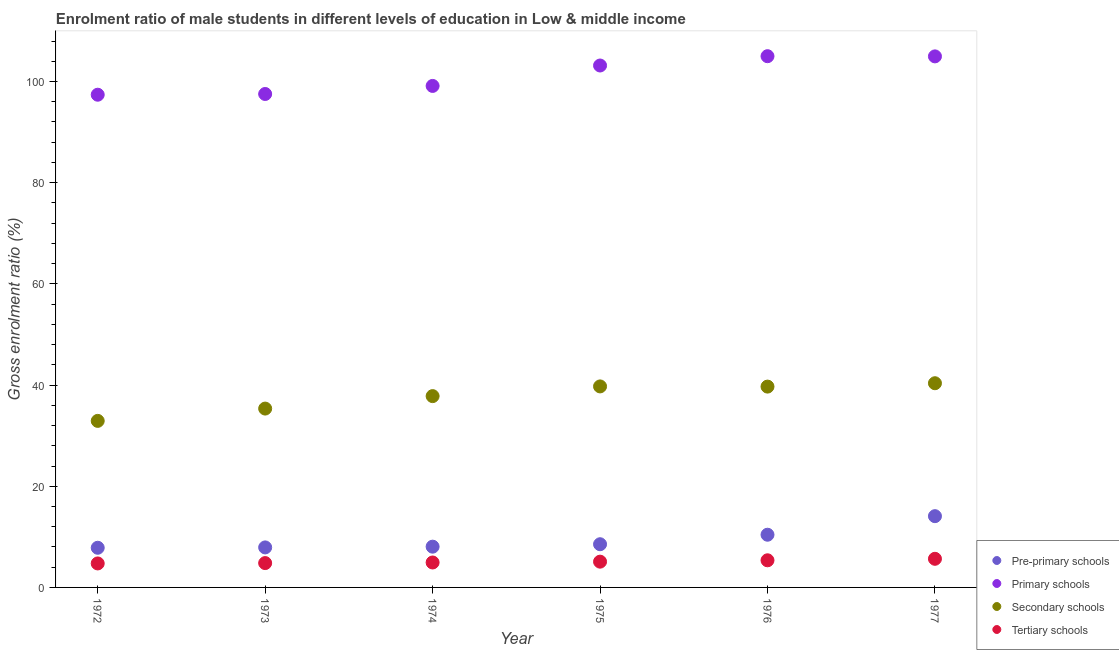How many different coloured dotlines are there?
Provide a short and direct response. 4. What is the gross enrolment ratio(female) in tertiary schools in 1977?
Give a very brief answer. 5.66. Across all years, what is the maximum gross enrolment ratio(female) in secondary schools?
Offer a terse response. 40.36. Across all years, what is the minimum gross enrolment ratio(female) in secondary schools?
Provide a succinct answer. 32.92. In which year was the gross enrolment ratio(female) in primary schools maximum?
Your answer should be compact. 1976. What is the total gross enrolment ratio(female) in primary schools in the graph?
Your answer should be compact. 607.19. What is the difference between the gross enrolment ratio(female) in pre-primary schools in 1976 and that in 1977?
Ensure brevity in your answer.  -3.67. What is the difference between the gross enrolment ratio(female) in tertiary schools in 1972 and the gross enrolment ratio(female) in secondary schools in 1976?
Give a very brief answer. -34.95. What is the average gross enrolment ratio(female) in pre-primary schools per year?
Provide a short and direct response. 9.47. In the year 1976, what is the difference between the gross enrolment ratio(female) in primary schools and gross enrolment ratio(female) in tertiary schools?
Provide a short and direct response. 99.64. In how many years, is the gross enrolment ratio(female) in secondary schools greater than 44 %?
Keep it short and to the point. 0. What is the ratio of the gross enrolment ratio(female) in tertiary schools in 1975 to that in 1977?
Provide a short and direct response. 0.9. Is the gross enrolment ratio(female) in pre-primary schools in 1974 less than that in 1977?
Provide a short and direct response. Yes. Is the difference between the gross enrolment ratio(female) in tertiary schools in 1972 and 1975 greater than the difference between the gross enrolment ratio(female) in pre-primary schools in 1972 and 1975?
Make the answer very short. Yes. What is the difference between the highest and the second highest gross enrolment ratio(female) in pre-primary schools?
Offer a terse response. 3.67. What is the difference between the highest and the lowest gross enrolment ratio(female) in secondary schools?
Ensure brevity in your answer.  7.44. Is it the case that in every year, the sum of the gross enrolment ratio(female) in pre-primary schools and gross enrolment ratio(female) in primary schools is greater than the gross enrolment ratio(female) in secondary schools?
Give a very brief answer. Yes. Is the gross enrolment ratio(female) in primary schools strictly greater than the gross enrolment ratio(female) in tertiary schools over the years?
Keep it short and to the point. Yes. What is the difference between two consecutive major ticks on the Y-axis?
Your answer should be very brief. 20. What is the title of the graph?
Your answer should be compact. Enrolment ratio of male students in different levels of education in Low & middle income. Does "Revenue mobilization" appear as one of the legend labels in the graph?
Provide a short and direct response. No. What is the Gross enrolment ratio (%) of Pre-primary schools in 1972?
Provide a short and direct response. 7.84. What is the Gross enrolment ratio (%) in Primary schools in 1972?
Make the answer very short. 97.39. What is the Gross enrolment ratio (%) of Secondary schools in 1972?
Keep it short and to the point. 32.92. What is the Gross enrolment ratio (%) of Tertiary schools in 1972?
Give a very brief answer. 4.74. What is the Gross enrolment ratio (%) of Pre-primary schools in 1973?
Provide a short and direct response. 7.91. What is the Gross enrolment ratio (%) in Primary schools in 1973?
Offer a very short reply. 97.53. What is the Gross enrolment ratio (%) in Secondary schools in 1973?
Give a very brief answer. 35.35. What is the Gross enrolment ratio (%) of Tertiary schools in 1973?
Provide a short and direct response. 4.81. What is the Gross enrolment ratio (%) in Pre-primary schools in 1974?
Give a very brief answer. 8.06. What is the Gross enrolment ratio (%) of Primary schools in 1974?
Your answer should be compact. 99.13. What is the Gross enrolment ratio (%) in Secondary schools in 1974?
Provide a short and direct response. 37.81. What is the Gross enrolment ratio (%) in Tertiary schools in 1974?
Give a very brief answer. 4.93. What is the Gross enrolment ratio (%) of Pre-primary schools in 1975?
Offer a terse response. 8.54. What is the Gross enrolment ratio (%) of Primary schools in 1975?
Give a very brief answer. 103.16. What is the Gross enrolment ratio (%) in Secondary schools in 1975?
Offer a terse response. 39.73. What is the Gross enrolment ratio (%) in Tertiary schools in 1975?
Make the answer very short. 5.09. What is the Gross enrolment ratio (%) in Pre-primary schools in 1976?
Your answer should be very brief. 10.42. What is the Gross enrolment ratio (%) in Primary schools in 1976?
Ensure brevity in your answer.  105.01. What is the Gross enrolment ratio (%) of Secondary schools in 1976?
Offer a terse response. 39.69. What is the Gross enrolment ratio (%) of Tertiary schools in 1976?
Make the answer very short. 5.36. What is the Gross enrolment ratio (%) in Pre-primary schools in 1977?
Ensure brevity in your answer.  14.09. What is the Gross enrolment ratio (%) of Primary schools in 1977?
Offer a terse response. 104.97. What is the Gross enrolment ratio (%) in Secondary schools in 1977?
Give a very brief answer. 40.36. What is the Gross enrolment ratio (%) of Tertiary schools in 1977?
Keep it short and to the point. 5.66. Across all years, what is the maximum Gross enrolment ratio (%) of Pre-primary schools?
Provide a short and direct response. 14.09. Across all years, what is the maximum Gross enrolment ratio (%) of Primary schools?
Offer a terse response. 105.01. Across all years, what is the maximum Gross enrolment ratio (%) of Secondary schools?
Keep it short and to the point. 40.36. Across all years, what is the maximum Gross enrolment ratio (%) in Tertiary schools?
Make the answer very short. 5.66. Across all years, what is the minimum Gross enrolment ratio (%) in Pre-primary schools?
Keep it short and to the point. 7.84. Across all years, what is the minimum Gross enrolment ratio (%) of Primary schools?
Your answer should be compact. 97.39. Across all years, what is the minimum Gross enrolment ratio (%) in Secondary schools?
Provide a short and direct response. 32.92. Across all years, what is the minimum Gross enrolment ratio (%) of Tertiary schools?
Your answer should be compact. 4.74. What is the total Gross enrolment ratio (%) in Pre-primary schools in the graph?
Provide a succinct answer. 56.85. What is the total Gross enrolment ratio (%) of Primary schools in the graph?
Offer a terse response. 607.19. What is the total Gross enrolment ratio (%) in Secondary schools in the graph?
Provide a succinct answer. 225.87. What is the total Gross enrolment ratio (%) in Tertiary schools in the graph?
Keep it short and to the point. 30.6. What is the difference between the Gross enrolment ratio (%) of Pre-primary schools in 1972 and that in 1973?
Make the answer very short. -0.07. What is the difference between the Gross enrolment ratio (%) of Primary schools in 1972 and that in 1973?
Offer a very short reply. -0.14. What is the difference between the Gross enrolment ratio (%) of Secondary schools in 1972 and that in 1973?
Provide a succinct answer. -2.43. What is the difference between the Gross enrolment ratio (%) of Tertiary schools in 1972 and that in 1973?
Offer a very short reply. -0.07. What is the difference between the Gross enrolment ratio (%) in Pre-primary schools in 1972 and that in 1974?
Provide a succinct answer. -0.22. What is the difference between the Gross enrolment ratio (%) of Primary schools in 1972 and that in 1974?
Keep it short and to the point. -1.74. What is the difference between the Gross enrolment ratio (%) of Secondary schools in 1972 and that in 1974?
Your answer should be very brief. -4.9. What is the difference between the Gross enrolment ratio (%) of Tertiary schools in 1972 and that in 1974?
Offer a very short reply. -0.19. What is the difference between the Gross enrolment ratio (%) in Pre-primary schools in 1972 and that in 1975?
Provide a succinct answer. -0.7. What is the difference between the Gross enrolment ratio (%) in Primary schools in 1972 and that in 1975?
Provide a short and direct response. -5.77. What is the difference between the Gross enrolment ratio (%) in Secondary schools in 1972 and that in 1975?
Your answer should be compact. -6.81. What is the difference between the Gross enrolment ratio (%) of Tertiary schools in 1972 and that in 1975?
Your answer should be compact. -0.35. What is the difference between the Gross enrolment ratio (%) of Pre-primary schools in 1972 and that in 1976?
Your answer should be very brief. -2.58. What is the difference between the Gross enrolment ratio (%) in Primary schools in 1972 and that in 1976?
Ensure brevity in your answer.  -7.62. What is the difference between the Gross enrolment ratio (%) of Secondary schools in 1972 and that in 1976?
Make the answer very short. -6.78. What is the difference between the Gross enrolment ratio (%) of Tertiary schools in 1972 and that in 1976?
Offer a very short reply. -0.62. What is the difference between the Gross enrolment ratio (%) in Pre-primary schools in 1972 and that in 1977?
Provide a succinct answer. -6.25. What is the difference between the Gross enrolment ratio (%) of Primary schools in 1972 and that in 1977?
Ensure brevity in your answer.  -7.58. What is the difference between the Gross enrolment ratio (%) of Secondary schools in 1972 and that in 1977?
Provide a short and direct response. -7.44. What is the difference between the Gross enrolment ratio (%) of Tertiary schools in 1972 and that in 1977?
Give a very brief answer. -0.92. What is the difference between the Gross enrolment ratio (%) in Pre-primary schools in 1973 and that in 1974?
Provide a succinct answer. -0.15. What is the difference between the Gross enrolment ratio (%) in Primary schools in 1973 and that in 1974?
Provide a short and direct response. -1.59. What is the difference between the Gross enrolment ratio (%) in Secondary schools in 1973 and that in 1974?
Provide a succinct answer. -2.46. What is the difference between the Gross enrolment ratio (%) in Tertiary schools in 1973 and that in 1974?
Provide a succinct answer. -0.12. What is the difference between the Gross enrolment ratio (%) of Pre-primary schools in 1973 and that in 1975?
Provide a succinct answer. -0.63. What is the difference between the Gross enrolment ratio (%) of Primary schools in 1973 and that in 1975?
Give a very brief answer. -5.63. What is the difference between the Gross enrolment ratio (%) in Secondary schools in 1973 and that in 1975?
Provide a short and direct response. -4.38. What is the difference between the Gross enrolment ratio (%) in Tertiary schools in 1973 and that in 1975?
Your answer should be compact. -0.28. What is the difference between the Gross enrolment ratio (%) of Pre-primary schools in 1973 and that in 1976?
Your answer should be compact. -2.51. What is the difference between the Gross enrolment ratio (%) in Primary schools in 1973 and that in 1976?
Keep it short and to the point. -7.47. What is the difference between the Gross enrolment ratio (%) in Secondary schools in 1973 and that in 1976?
Your answer should be compact. -4.34. What is the difference between the Gross enrolment ratio (%) in Tertiary schools in 1973 and that in 1976?
Your response must be concise. -0.55. What is the difference between the Gross enrolment ratio (%) in Pre-primary schools in 1973 and that in 1977?
Your answer should be compact. -6.18. What is the difference between the Gross enrolment ratio (%) of Primary schools in 1973 and that in 1977?
Your answer should be compact. -7.43. What is the difference between the Gross enrolment ratio (%) of Secondary schools in 1973 and that in 1977?
Your response must be concise. -5.01. What is the difference between the Gross enrolment ratio (%) of Tertiary schools in 1973 and that in 1977?
Give a very brief answer. -0.85. What is the difference between the Gross enrolment ratio (%) of Pre-primary schools in 1974 and that in 1975?
Provide a succinct answer. -0.48. What is the difference between the Gross enrolment ratio (%) of Primary schools in 1974 and that in 1975?
Provide a short and direct response. -4.04. What is the difference between the Gross enrolment ratio (%) in Secondary schools in 1974 and that in 1975?
Provide a succinct answer. -1.92. What is the difference between the Gross enrolment ratio (%) in Tertiary schools in 1974 and that in 1975?
Provide a succinct answer. -0.16. What is the difference between the Gross enrolment ratio (%) of Pre-primary schools in 1974 and that in 1976?
Ensure brevity in your answer.  -2.36. What is the difference between the Gross enrolment ratio (%) in Primary schools in 1974 and that in 1976?
Provide a short and direct response. -5.88. What is the difference between the Gross enrolment ratio (%) of Secondary schools in 1974 and that in 1976?
Keep it short and to the point. -1.88. What is the difference between the Gross enrolment ratio (%) of Tertiary schools in 1974 and that in 1976?
Give a very brief answer. -0.43. What is the difference between the Gross enrolment ratio (%) of Pre-primary schools in 1974 and that in 1977?
Make the answer very short. -6.03. What is the difference between the Gross enrolment ratio (%) in Primary schools in 1974 and that in 1977?
Your response must be concise. -5.84. What is the difference between the Gross enrolment ratio (%) of Secondary schools in 1974 and that in 1977?
Provide a succinct answer. -2.55. What is the difference between the Gross enrolment ratio (%) in Tertiary schools in 1974 and that in 1977?
Offer a terse response. -0.73. What is the difference between the Gross enrolment ratio (%) of Pre-primary schools in 1975 and that in 1976?
Provide a succinct answer. -1.88. What is the difference between the Gross enrolment ratio (%) in Primary schools in 1975 and that in 1976?
Provide a short and direct response. -1.84. What is the difference between the Gross enrolment ratio (%) in Secondary schools in 1975 and that in 1976?
Your answer should be compact. 0.04. What is the difference between the Gross enrolment ratio (%) in Tertiary schools in 1975 and that in 1976?
Make the answer very short. -0.27. What is the difference between the Gross enrolment ratio (%) of Pre-primary schools in 1975 and that in 1977?
Ensure brevity in your answer.  -5.55. What is the difference between the Gross enrolment ratio (%) of Primary schools in 1975 and that in 1977?
Keep it short and to the point. -1.8. What is the difference between the Gross enrolment ratio (%) of Secondary schools in 1975 and that in 1977?
Provide a short and direct response. -0.63. What is the difference between the Gross enrolment ratio (%) in Tertiary schools in 1975 and that in 1977?
Your answer should be compact. -0.57. What is the difference between the Gross enrolment ratio (%) of Pre-primary schools in 1976 and that in 1977?
Keep it short and to the point. -3.67. What is the difference between the Gross enrolment ratio (%) of Primary schools in 1976 and that in 1977?
Offer a terse response. 0.04. What is the difference between the Gross enrolment ratio (%) of Secondary schools in 1976 and that in 1977?
Make the answer very short. -0.67. What is the difference between the Gross enrolment ratio (%) of Tertiary schools in 1976 and that in 1977?
Give a very brief answer. -0.3. What is the difference between the Gross enrolment ratio (%) of Pre-primary schools in 1972 and the Gross enrolment ratio (%) of Primary schools in 1973?
Provide a short and direct response. -89.7. What is the difference between the Gross enrolment ratio (%) in Pre-primary schools in 1972 and the Gross enrolment ratio (%) in Secondary schools in 1973?
Offer a very short reply. -27.51. What is the difference between the Gross enrolment ratio (%) of Pre-primary schools in 1972 and the Gross enrolment ratio (%) of Tertiary schools in 1973?
Make the answer very short. 3.03. What is the difference between the Gross enrolment ratio (%) of Primary schools in 1972 and the Gross enrolment ratio (%) of Secondary schools in 1973?
Provide a short and direct response. 62.04. What is the difference between the Gross enrolment ratio (%) of Primary schools in 1972 and the Gross enrolment ratio (%) of Tertiary schools in 1973?
Ensure brevity in your answer.  92.58. What is the difference between the Gross enrolment ratio (%) in Secondary schools in 1972 and the Gross enrolment ratio (%) in Tertiary schools in 1973?
Your response must be concise. 28.11. What is the difference between the Gross enrolment ratio (%) in Pre-primary schools in 1972 and the Gross enrolment ratio (%) in Primary schools in 1974?
Give a very brief answer. -91.29. What is the difference between the Gross enrolment ratio (%) in Pre-primary schools in 1972 and the Gross enrolment ratio (%) in Secondary schools in 1974?
Provide a succinct answer. -29.98. What is the difference between the Gross enrolment ratio (%) of Pre-primary schools in 1972 and the Gross enrolment ratio (%) of Tertiary schools in 1974?
Provide a short and direct response. 2.91. What is the difference between the Gross enrolment ratio (%) of Primary schools in 1972 and the Gross enrolment ratio (%) of Secondary schools in 1974?
Provide a short and direct response. 59.58. What is the difference between the Gross enrolment ratio (%) of Primary schools in 1972 and the Gross enrolment ratio (%) of Tertiary schools in 1974?
Your answer should be compact. 92.46. What is the difference between the Gross enrolment ratio (%) of Secondary schools in 1972 and the Gross enrolment ratio (%) of Tertiary schools in 1974?
Provide a short and direct response. 27.99. What is the difference between the Gross enrolment ratio (%) in Pre-primary schools in 1972 and the Gross enrolment ratio (%) in Primary schools in 1975?
Provide a succinct answer. -95.32. What is the difference between the Gross enrolment ratio (%) of Pre-primary schools in 1972 and the Gross enrolment ratio (%) of Secondary schools in 1975?
Your response must be concise. -31.89. What is the difference between the Gross enrolment ratio (%) in Pre-primary schools in 1972 and the Gross enrolment ratio (%) in Tertiary schools in 1975?
Ensure brevity in your answer.  2.75. What is the difference between the Gross enrolment ratio (%) of Primary schools in 1972 and the Gross enrolment ratio (%) of Secondary schools in 1975?
Provide a short and direct response. 57.66. What is the difference between the Gross enrolment ratio (%) of Primary schools in 1972 and the Gross enrolment ratio (%) of Tertiary schools in 1975?
Your answer should be very brief. 92.3. What is the difference between the Gross enrolment ratio (%) of Secondary schools in 1972 and the Gross enrolment ratio (%) of Tertiary schools in 1975?
Keep it short and to the point. 27.83. What is the difference between the Gross enrolment ratio (%) in Pre-primary schools in 1972 and the Gross enrolment ratio (%) in Primary schools in 1976?
Keep it short and to the point. -97.17. What is the difference between the Gross enrolment ratio (%) of Pre-primary schools in 1972 and the Gross enrolment ratio (%) of Secondary schools in 1976?
Your answer should be very brief. -31.86. What is the difference between the Gross enrolment ratio (%) of Pre-primary schools in 1972 and the Gross enrolment ratio (%) of Tertiary schools in 1976?
Provide a short and direct response. 2.48. What is the difference between the Gross enrolment ratio (%) in Primary schools in 1972 and the Gross enrolment ratio (%) in Secondary schools in 1976?
Your answer should be very brief. 57.7. What is the difference between the Gross enrolment ratio (%) in Primary schools in 1972 and the Gross enrolment ratio (%) in Tertiary schools in 1976?
Your response must be concise. 92.03. What is the difference between the Gross enrolment ratio (%) in Secondary schools in 1972 and the Gross enrolment ratio (%) in Tertiary schools in 1976?
Keep it short and to the point. 27.56. What is the difference between the Gross enrolment ratio (%) of Pre-primary schools in 1972 and the Gross enrolment ratio (%) of Primary schools in 1977?
Provide a short and direct response. -97.13. What is the difference between the Gross enrolment ratio (%) in Pre-primary schools in 1972 and the Gross enrolment ratio (%) in Secondary schools in 1977?
Provide a short and direct response. -32.52. What is the difference between the Gross enrolment ratio (%) in Pre-primary schools in 1972 and the Gross enrolment ratio (%) in Tertiary schools in 1977?
Your response must be concise. 2.18. What is the difference between the Gross enrolment ratio (%) of Primary schools in 1972 and the Gross enrolment ratio (%) of Secondary schools in 1977?
Provide a succinct answer. 57.03. What is the difference between the Gross enrolment ratio (%) in Primary schools in 1972 and the Gross enrolment ratio (%) in Tertiary schools in 1977?
Provide a short and direct response. 91.73. What is the difference between the Gross enrolment ratio (%) in Secondary schools in 1972 and the Gross enrolment ratio (%) in Tertiary schools in 1977?
Your response must be concise. 27.26. What is the difference between the Gross enrolment ratio (%) of Pre-primary schools in 1973 and the Gross enrolment ratio (%) of Primary schools in 1974?
Your answer should be compact. -91.22. What is the difference between the Gross enrolment ratio (%) of Pre-primary schools in 1973 and the Gross enrolment ratio (%) of Secondary schools in 1974?
Offer a very short reply. -29.91. What is the difference between the Gross enrolment ratio (%) in Pre-primary schools in 1973 and the Gross enrolment ratio (%) in Tertiary schools in 1974?
Your answer should be compact. 2.98. What is the difference between the Gross enrolment ratio (%) in Primary schools in 1973 and the Gross enrolment ratio (%) in Secondary schools in 1974?
Provide a succinct answer. 59.72. What is the difference between the Gross enrolment ratio (%) in Primary schools in 1973 and the Gross enrolment ratio (%) in Tertiary schools in 1974?
Make the answer very short. 92.61. What is the difference between the Gross enrolment ratio (%) of Secondary schools in 1973 and the Gross enrolment ratio (%) of Tertiary schools in 1974?
Ensure brevity in your answer.  30.42. What is the difference between the Gross enrolment ratio (%) of Pre-primary schools in 1973 and the Gross enrolment ratio (%) of Primary schools in 1975?
Keep it short and to the point. -95.25. What is the difference between the Gross enrolment ratio (%) of Pre-primary schools in 1973 and the Gross enrolment ratio (%) of Secondary schools in 1975?
Offer a very short reply. -31.82. What is the difference between the Gross enrolment ratio (%) of Pre-primary schools in 1973 and the Gross enrolment ratio (%) of Tertiary schools in 1975?
Provide a succinct answer. 2.82. What is the difference between the Gross enrolment ratio (%) of Primary schools in 1973 and the Gross enrolment ratio (%) of Secondary schools in 1975?
Offer a very short reply. 57.8. What is the difference between the Gross enrolment ratio (%) in Primary schools in 1973 and the Gross enrolment ratio (%) in Tertiary schools in 1975?
Offer a terse response. 92.44. What is the difference between the Gross enrolment ratio (%) of Secondary schools in 1973 and the Gross enrolment ratio (%) of Tertiary schools in 1975?
Your answer should be compact. 30.26. What is the difference between the Gross enrolment ratio (%) of Pre-primary schools in 1973 and the Gross enrolment ratio (%) of Primary schools in 1976?
Offer a very short reply. -97.1. What is the difference between the Gross enrolment ratio (%) in Pre-primary schools in 1973 and the Gross enrolment ratio (%) in Secondary schools in 1976?
Keep it short and to the point. -31.79. What is the difference between the Gross enrolment ratio (%) in Pre-primary schools in 1973 and the Gross enrolment ratio (%) in Tertiary schools in 1976?
Your answer should be very brief. 2.55. What is the difference between the Gross enrolment ratio (%) in Primary schools in 1973 and the Gross enrolment ratio (%) in Secondary schools in 1976?
Your answer should be very brief. 57.84. What is the difference between the Gross enrolment ratio (%) in Primary schools in 1973 and the Gross enrolment ratio (%) in Tertiary schools in 1976?
Your response must be concise. 92.17. What is the difference between the Gross enrolment ratio (%) of Secondary schools in 1973 and the Gross enrolment ratio (%) of Tertiary schools in 1976?
Ensure brevity in your answer.  29.99. What is the difference between the Gross enrolment ratio (%) of Pre-primary schools in 1973 and the Gross enrolment ratio (%) of Primary schools in 1977?
Your response must be concise. -97.06. What is the difference between the Gross enrolment ratio (%) in Pre-primary schools in 1973 and the Gross enrolment ratio (%) in Secondary schools in 1977?
Offer a very short reply. -32.45. What is the difference between the Gross enrolment ratio (%) of Pre-primary schools in 1973 and the Gross enrolment ratio (%) of Tertiary schools in 1977?
Keep it short and to the point. 2.25. What is the difference between the Gross enrolment ratio (%) in Primary schools in 1973 and the Gross enrolment ratio (%) in Secondary schools in 1977?
Offer a very short reply. 57.17. What is the difference between the Gross enrolment ratio (%) in Primary schools in 1973 and the Gross enrolment ratio (%) in Tertiary schools in 1977?
Provide a succinct answer. 91.88. What is the difference between the Gross enrolment ratio (%) in Secondary schools in 1973 and the Gross enrolment ratio (%) in Tertiary schools in 1977?
Offer a very short reply. 29.69. What is the difference between the Gross enrolment ratio (%) of Pre-primary schools in 1974 and the Gross enrolment ratio (%) of Primary schools in 1975?
Offer a terse response. -95.11. What is the difference between the Gross enrolment ratio (%) in Pre-primary schools in 1974 and the Gross enrolment ratio (%) in Secondary schools in 1975?
Give a very brief answer. -31.68. What is the difference between the Gross enrolment ratio (%) in Pre-primary schools in 1974 and the Gross enrolment ratio (%) in Tertiary schools in 1975?
Ensure brevity in your answer.  2.96. What is the difference between the Gross enrolment ratio (%) in Primary schools in 1974 and the Gross enrolment ratio (%) in Secondary schools in 1975?
Offer a very short reply. 59.4. What is the difference between the Gross enrolment ratio (%) of Primary schools in 1974 and the Gross enrolment ratio (%) of Tertiary schools in 1975?
Your answer should be very brief. 94.03. What is the difference between the Gross enrolment ratio (%) in Secondary schools in 1974 and the Gross enrolment ratio (%) in Tertiary schools in 1975?
Your answer should be compact. 32.72. What is the difference between the Gross enrolment ratio (%) of Pre-primary schools in 1974 and the Gross enrolment ratio (%) of Primary schools in 1976?
Offer a very short reply. -96.95. What is the difference between the Gross enrolment ratio (%) of Pre-primary schools in 1974 and the Gross enrolment ratio (%) of Secondary schools in 1976?
Give a very brief answer. -31.64. What is the difference between the Gross enrolment ratio (%) in Pre-primary schools in 1974 and the Gross enrolment ratio (%) in Tertiary schools in 1976?
Your answer should be very brief. 2.69. What is the difference between the Gross enrolment ratio (%) in Primary schools in 1974 and the Gross enrolment ratio (%) in Secondary schools in 1976?
Offer a very short reply. 59.43. What is the difference between the Gross enrolment ratio (%) in Primary schools in 1974 and the Gross enrolment ratio (%) in Tertiary schools in 1976?
Ensure brevity in your answer.  93.76. What is the difference between the Gross enrolment ratio (%) of Secondary schools in 1974 and the Gross enrolment ratio (%) of Tertiary schools in 1976?
Provide a short and direct response. 32.45. What is the difference between the Gross enrolment ratio (%) of Pre-primary schools in 1974 and the Gross enrolment ratio (%) of Primary schools in 1977?
Give a very brief answer. -96.91. What is the difference between the Gross enrolment ratio (%) in Pre-primary schools in 1974 and the Gross enrolment ratio (%) in Secondary schools in 1977?
Provide a short and direct response. -32.31. What is the difference between the Gross enrolment ratio (%) of Pre-primary schools in 1974 and the Gross enrolment ratio (%) of Tertiary schools in 1977?
Your answer should be very brief. 2.4. What is the difference between the Gross enrolment ratio (%) of Primary schools in 1974 and the Gross enrolment ratio (%) of Secondary schools in 1977?
Your response must be concise. 58.77. What is the difference between the Gross enrolment ratio (%) of Primary schools in 1974 and the Gross enrolment ratio (%) of Tertiary schools in 1977?
Your answer should be compact. 93.47. What is the difference between the Gross enrolment ratio (%) of Secondary schools in 1974 and the Gross enrolment ratio (%) of Tertiary schools in 1977?
Your answer should be very brief. 32.16. What is the difference between the Gross enrolment ratio (%) of Pre-primary schools in 1975 and the Gross enrolment ratio (%) of Primary schools in 1976?
Offer a very short reply. -96.47. What is the difference between the Gross enrolment ratio (%) in Pre-primary schools in 1975 and the Gross enrolment ratio (%) in Secondary schools in 1976?
Offer a very short reply. -31.16. What is the difference between the Gross enrolment ratio (%) of Pre-primary schools in 1975 and the Gross enrolment ratio (%) of Tertiary schools in 1976?
Make the answer very short. 3.17. What is the difference between the Gross enrolment ratio (%) in Primary schools in 1975 and the Gross enrolment ratio (%) in Secondary schools in 1976?
Your answer should be very brief. 63.47. What is the difference between the Gross enrolment ratio (%) in Primary schools in 1975 and the Gross enrolment ratio (%) in Tertiary schools in 1976?
Keep it short and to the point. 97.8. What is the difference between the Gross enrolment ratio (%) in Secondary schools in 1975 and the Gross enrolment ratio (%) in Tertiary schools in 1976?
Keep it short and to the point. 34.37. What is the difference between the Gross enrolment ratio (%) in Pre-primary schools in 1975 and the Gross enrolment ratio (%) in Primary schools in 1977?
Your answer should be compact. -96.43. What is the difference between the Gross enrolment ratio (%) of Pre-primary schools in 1975 and the Gross enrolment ratio (%) of Secondary schools in 1977?
Offer a very short reply. -31.82. What is the difference between the Gross enrolment ratio (%) in Pre-primary schools in 1975 and the Gross enrolment ratio (%) in Tertiary schools in 1977?
Your response must be concise. 2.88. What is the difference between the Gross enrolment ratio (%) in Primary schools in 1975 and the Gross enrolment ratio (%) in Secondary schools in 1977?
Make the answer very short. 62.8. What is the difference between the Gross enrolment ratio (%) in Primary schools in 1975 and the Gross enrolment ratio (%) in Tertiary schools in 1977?
Offer a very short reply. 97.51. What is the difference between the Gross enrolment ratio (%) in Secondary schools in 1975 and the Gross enrolment ratio (%) in Tertiary schools in 1977?
Provide a short and direct response. 34.07. What is the difference between the Gross enrolment ratio (%) of Pre-primary schools in 1976 and the Gross enrolment ratio (%) of Primary schools in 1977?
Give a very brief answer. -94.55. What is the difference between the Gross enrolment ratio (%) in Pre-primary schools in 1976 and the Gross enrolment ratio (%) in Secondary schools in 1977?
Ensure brevity in your answer.  -29.95. What is the difference between the Gross enrolment ratio (%) of Pre-primary schools in 1976 and the Gross enrolment ratio (%) of Tertiary schools in 1977?
Keep it short and to the point. 4.76. What is the difference between the Gross enrolment ratio (%) in Primary schools in 1976 and the Gross enrolment ratio (%) in Secondary schools in 1977?
Your response must be concise. 64.64. What is the difference between the Gross enrolment ratio (%) of Primary schools in 1976 and the Gross enrolment ratio (%) of Tertiary schools in 1977?
Provide a succinct answer. 99.35. What is the difference between the Gross enrolment ratio (%) of Secondary schools in 1976 and the Gross enrolment ratio (%) of Tertiary schools in 1977?
Provide a succinct answer. 34.04. What is the average Gross enrolment ratio (%) of Pre-primary schools per year?
Keep it short and to the point. 9.47. What is the average Gross enrolment ratio (%) in Primary schools per year?
Offer a very short reply. 101.2. What is the average Gross enrolment ratio (%) in Secondary schools per year?
Provide a succinct answer. 37.65. What is the average Gross enrolment ratio (%) of Tertiary schools per year?
Give a very brief answer. 5.1. In the year 1972, what is the difference between the Gross enrolment ratio (%) in Pre-primary schools and Gross enrolment ratio (%) in Primary schools?
Give a very brief answer. -89.55. In the year 1972, what is the difference between the Gross enrolment ratio (%) of Pre-primary schools and Gross enrolment ratio (%) of Secondary schools?
Your answer should be compact. -25.08. In the year 1972, what is the difference between the Gross enrolment ratio (%) of Pre-primary schools and Gross enrolment ratio (%) of Tertiary schools?
Your answer should be very brief. 3.1. In the year 1972, what is the difference between the Gross enrolment ratio (%) of Primary schools and Gross enrolment ratio (%) of Secondary schools?
Offer a very short reply. 64.47. In the year 1972, what is the difference between the Gross enrolment ratio (%) of Primary schools and Gross enrolment ratio (%) of Tertiary schools?
Keep it short and to the point. 92.65. In the year 1972, what is the difference between the Gross enrolment ratio (%) of Secondary schools and Gross enrolment ratio (%) of Tertiary schools?
Your response must be concise. 28.18. In the year 1973, what is the difference between the Gross enrolment ratio (%) of Pre-primary schools and Gross enrolment ratio (%) of Primary schools?
Your answer should be very brief. -89.63. In the year 1973, what is the difference between the Gross enrolment ratio (%) of Pre-primary schools and Gross enrolment ratio (%) of Secondary schools?
Ensure brevity in your answer.  -27.44. In the year 1973, what is the difference between the Gross enrolment ratio (%) in Pre-primary schools and Gross enrolment ratio (%) in Tertiary schools?
Provide a short and direct response. 3.1. In the year 1973, what is the difference between the Gross enrolment ratio (%) of Primary schools and Gross enrolment ratio (%) of Secondary schools?
Make the answer very short. 62.18. In the year 1973, what is the difference between the Gross enrolment ratio (%) in Primary schools and Gross enrolment ratio (%) in Tertiary schools?
Provide a succinct answer. 92.72. In the year 1973, what is the difference between the Gross enrolment ratio (%) in Secondary schools and Gross enrolment ratio (%) in Tertiary schools?
Offer a terse response. 30.54. In the year 1974, what is the difference between the Gross enrolment ratio (%) of Pre-primary schools and Gross enrolment ratio (%) of Primary schools?
Keep it short and to the point. -91.07. In the year 1974, what is the difference between the Gross enrolment ratio (%) in Pre-primary schools and Gross enrolment ratio (%) in Secondary schools?
Ensure brevity in your answer.  -29.76. In the year 1974, what is the difference between the Gross enrolment ratio (%) in Pre-primary schools and Gross enrolment ratio (%) in Tertiary schools?
Your answer should be compact. 3.13. In the year 1974, what is the difference between the Gross enrolment ratio (%) in Primary schools and Gross enrolment ratio (%) in Secondary schools?
Make the answer very short. 61.31. In the year 1974, what is the difference between the Gross enrolment ratio (%) of Primary schools and Gross enrolment ratio (%) of Tertiary schools?
Provide a succinct answer. 94.2. In the year 1974, what is the difference between the Gross enrolment ratio (%) of Secondary schools and Gross enrolment ratio (%) of Tertiary schools?
Provide a short and direct response. 32.89. In the year 1975, what is the difference between the Gross enrolment ratio (%) of Pre-primary schools and Gross enrolment ratio (%) of Primary schools?
Your answer should be compact. -94.63. In the year 1975, what is the difference between the Gross enrolment ratio (%) in Pre-primary schools and Gross enrolment ratio (%) in Secondary schools?
Offer a very short reply. -31.19. In the year 1975, what is the difference between the Gross enrolment ratio (%) of Pre-primary schools and Gross enrolment ratio (%) of Tertiary schools?
Give a very brief answer. 3.44. In the year 1975, what is the difference between the Gross enrolment ratio (%) of Primary schools and Gross enrolment ratio (%) of Secondary schools?
Offer a terse response. 63.43. In the year 1975, what is the difference between the Gross enrolment ratio (%) of Primary schools and Gross enrolment ratio (%) of Tertiary schools?
Offer a very short reply. 98.07. In the year 1975, what is the difference between the Gross enrolment ratio (%) of Secondary schools and Gross enrolment ratio (%) of Tertiary schools?
Your answer should be compact. 34.64. In the year 1976, what is the difference between the Gross enrolment ratio (%) in Pre-primary schools and Gross enrolment ratio (%) in Primary schools?
Your answer should be very brief. -94.59. In the year 1976, what is the difference between the Gross enrolment ratio (%) of Pre-primary schools and Gross enrolment ratio (%) of Secondary schools?
Provide a succinct answer. -29.28. In the year 1976, what is the difference between the Gross enrolment ratio (%) of Pre-primary schools and Gross enrolment ratio (%) of Tertiary schools?
Make the answer very short. 5.05. In the year 1976, what is the difference between the Gross enrolment ratio (%) of Primary schools and Gross enrolment ratio (%) of Secondary schools?
Offer a very short reply. 65.31. In the year 1976, what is the difference between the Gross enrolment ratio (%) in Primary schools and Gross enrolment ratio (%) in Tertiary schools?
Offer a terse response. 99.64. In the year 1976, what is the difference between the Gross enrolment ratio (%) of Secondary schools and Gross enrolment ratio (%) of Tertiary schools?
Provide a succinct answer. 34.33. In the year 1977, what is the difference between the Gross enrolment ratio (%) of Pre-primary schools and Gross enrolment ratio (%) of Primary schools?
Your answer should be very brief. -90.88. In the year 1977, what is the difference between the Gross enrolment ratio (%) in Pre-primary schools and Gross enrolment ratio (%) in Secondary schools?
Give a very brief answer. -26.28. In the year 1977, what is the difference between the Gross enrolment ratio (%) in Pre-primary schools and Gross enrolment ratio (%) in Tertiary schools?
Your answer should be very brief. 8.43. In the year 1977, what is the difference between the Gross enrolment ratio (%) of Primary schools and Gross enrolment ratio (%) of Secondary schools?
Provide a succinct answer. 64.61. In the year 1977, what is the difference between the Gross enrolment ratio (%) in Primary schools and Gross enrolment ratio (%) in Tertiary schools?
Ensure brevity in your answer.  99.31. In the year 1977, what is the difference between the Gross enrolment ratio (%) of Secondary schools and Gross enrolment ratio (%) of Tertiary schools?
Keep it short and to the point. 34.7. What is the ratio of the Gross enrolment ratio (%) in Primary schools in 1972 to that in 1973?
Offer a very short reply. 1. What is the ratio of the Gross enrolment ratio (%) of Secondary schools in 1972 to that in 1973?
Keep it short and to the point. 0.93. What is the ratio of the Gross enrolment ratio (%) of Tertiary schools in 1972 to that in 1973?
Keep it short and to the point. 0.99. What is the ratio of the Gross enrolment ratio (%) in Pre-primary schools in 1972 to that in 1974?
Offer a terse response. 0.97. What is the ratio of the Gross enrolment ratio (%) of Primary schools in 1972 to that in 1974?
Your answer should be compact. 0.98. What is the ratio of the Gross enrolment ratio (%) in Secondary schools in 1972 to that in 1974?
Offer a terse response. 0.87. What is the ratio of the Gross enrolment ratio (%) of Tertiary schools in 1972 to that in 1974?
Your response must be concise. 0.96. What is the ratio of the Gross enrolment ratio (%) of Pre-primary schools in 1972 to that in 1975?
Your answer should be compact. 0.92. What is the ratio of the Gross enrolment ratio (%) of Primary schools in 1972 to that in 1975?
Offer a very short reply. 0.94. What is the ratio of the Gross enrolment ratio (%) in Secondary schools in 1972 to that in 1975?
Your response must be concise. 0.83. What is the ratio of the Gross enrolment ratio (%) in Tertiary schools in 1972 to that in 1975?
Your response must be concise. 0.93. What is the ratio of the Gross enrolment ratio (%) in Pre-primary schools in 1972 to that in 1976?
Offer a terse response. 0.75. What is the ratio of the Gross enrolment ratio (%) of Primary schools in 1972 to that in 1976?
Keep it short and to the point. 0.93. What is the ratio of the Gross enrolment ratio (%) in Secondary schools in 1972 to that in 1976?
Provide a short and direct response. 0.83. What is the ratio of the Gross enrolment ratio (%) of Tertiary schools in 1972 to that in 1976?
Offer a terse response. 0.88. What is the ratio of the Gross enrolment ratio (%) of Pre-primary schools in 1972 to that in 1977?
Make the answer very short. 0.56. What is the ratio of the Gross enrolment ratio (%) of Primary schools in 1972 to that in 1977?
Provide a short and direct response. 0.93. What is the ratio of the Gross enrolment ratio (%) in Secondary schools in 1972 to that in 1977?
Your response must be concise. 0.82. What is the ratio of the Gross enrolment ratio (%) in Tertiary schools in 1972 to that in 1977?
Provide a succinct answer. 0.84. What is the ratio of the Gross enrolment ratio (%) in Pre-primary schools in 1973 to that in 1974?
Offer a very short reply. 0.98. What is the ratio of the Gross enrolment ratio (%) in Primary schools in 1973 to that in 1974?
Offer a terse response. 0.98. What is the ratio of the Gross enrolment ratio (%) of Secondary schools in 1973 to that in 1974?
Your answer should be very brief. 0.93. What is the ratio of the Gross enrolment ratio (%) in Tertiary schools in 1973 to that in 1974?
Provide a succinct answer. 0.98. What is the ratio of the Gross enrolment ratio (%) of Pre-primary schools in 1973 to that in 1975?
Give a very brief answer. 0.93. What is the ratio of the Gross enrolment ratio (%) in Primary schools in 1973 to that in 1975?
Provide a short and direct response. 0.95. What is the ratio of the Gross enrolment ratio (%) in Secondary schools in 1973 to that in 1975?
Keep it short and to the point. 0.89. What is the ratio of the Gross enrolment ratio (%) in Tertiary schools in 1973 to that in 1975?
Keep it short and to the point. 0.94. What is the ratio of the Gross enrolment ratio (%) of Pre-primary schools in 1973 to that in 1976?
Offer a terse response. 0.76. What is the ratio of the Gross enrolment ratio (%) in Primary schools in 1973 to that in 1976?
Your response must be concise. 0.93. What is the ratio of the Gross enrolment ratio (%) of Secondary schools in 1973 to that in 1976?
Ensure brevity in your answer.  0.89. What is the ratio of the Gross enrolment ratio (%) of Tertiary schools in 1973 to that in 1976?
Ensure brevity in your answer.  0.9. What is the ratio of the Gross enrolment ratio (%) of Pre-primary schools in 1973 to that in 1977?
Give a very brief answer. 0.56. What is the ratio of the Gross enrolment ratio (%) in Primary schools in 1973 to that in 1977?
Give a very brief answer. 0.93. What is the ratio of the Gross enrolment ratio (%) in Secondary schools in 1973 to that in 1977?
Offer a very short reply. 0.88. What is the ratio of the Gross enrolment ratio (%) of Tertiary schools in 1973 to that in 1977?
Make the answer very short. 0.85. What is the ratio of the Gross enrolment ratio (%) in Pre-primary schools in 1974 to that in 1975?
Provide a short and direct response. 0.94. What is the ratio of the Gross enrolment ratio (%) in Primary schools in 1974 to that in 1975?
Make the answer very short. 0.96. What is the ratio of the Gross enrolment ratio (%) of Secondary schools in 1974 to that in 1975?
Provide a succinct answer. 0.95. What is the ratio of the Gross enrolment ratio (%) in Tertiary schools in 1974 to that in 1975?
Ensure brevity in your answer.  0.97. What is the ratio of the Gross enrolment ratio (%) of Pre-primary schools in 1974 to that in 1976?
Provide a succinct answer. 0.77. What is the ratio of the Gross enrolment ratio (%) of Primary schools in 1974 to that in 1976?
Provide a succinct answer. 0.94. What is the ratio of the Gross enrolment ratio (%) of Secondary schools in 1974 to that in 1976?
Your answer should be very brief. 0.95. What is the ratio of the Gross enrolment ratio (%) of Tertiary schools in 1974 to that in 1976?
Offer a terse response. 0.92. What is the ratio of the Gross enrolment ratio (%) of Pre-primary schools in 1974 to that in 1977?
Provide a succinct answer. 0.57. What is the ratio of the Gross enrolment ratio (%) of Primary schools in 1974 to that in 1977?
Your response must be concise. 0.94. What is the ratio of the Gross enrolment ratio (%) in Secondary schools in 1974 to that in 1977?
Your response must be concise. 0.94. What is the ratio of the Gross enrolment ratio (%) in Tertiary schools in 1974 to that in 1977?
Provide a short and direct response. 0.87. What is the ratio of the Gross enrolment ratio (%) in Pre-primary schools in 1975 to that in 1976?
Make the answer very short. 0.82. What is the ratio of the Gross enrolment ratio (%) of Primary schools in 1975 to that in 1976?
Give a very brief answer. 0.98. What is the ratio of the Gross enrolment ratio (%) in Secondary schools in 1975 to that in 1976?
Your answer should be very brief. 1. What is the ratio of the Gross enrolment ratio (%) in Tertiary schools in 1975 to that in 1976?
Provide a succinct answer. 0.95. What is the ratio of the Gross enrolment ratio (%) of Pre-primary schools in 1975 to that in 1977?
Give a very brief answer. 0.61. What is the ratio of the Gross enrolment ratio (%) of Primary schools in 1975 to that in 1977?
Provide a succinct answer. 0.98. What is the ratio of the Gross enrolment ratio (%) of Secondary schools in 1975 to that in 1977?
Give a very brief answer. 0.98. What is the ratio of the Gross enrolment ratio (%) in Tertiary schools in 1975 to that in 1977?
Give a very brief answer. 0.9. What is the ratio of the Gross enrolment ratio (%) in Pre-primary schools in 1976 to that in 1977?
Offer a terse response. 0.74. What is the ratio of the Gross enrolment ratio (%) of Secondary schools in 1976 to that in 1977?
Your response must be concise. 0.98. What is the ratio of the Gross enrolment ratio (%) of Tertiary schools in 1976 to that in 1977?
Give a very brief answer. 0.95. What is the difference between the highest and the second highest Gross enrolment ratio (%) in Pre-primary schools?
Keep it short and to the point. 3.67. What is the difference between the highest and the second highest Gross enrolment ratio (%) in Primary schools?
Offer a terse response. 0.04. What is the difference between the highest and the second highest Gross enrolment ratio (%) of Secondary schools?
Your answer should be compact. 0.63. What is the difference between the highest and the second highest Gross enrolment ratio (%) of Tertiary schools?
Provide a short and direct response. 0.3. What is the difference between the highest and the lowest Gross enrolment ratio (%) of Pre-primary schools?
Your response must be concise. 6.25. What is the difference between the highest and the lowest Gross enrolment ratio (%) in Primary schools?
Your answer should be compact. 7.62. What is the difference between the highest and the lowest Gross enrolment ratio (%) in Secondary schools?
Offer a terse response. 7.44. What is the difference between the highest and the lowest Gross enrolment ratio (%) of Tertiary schools?
Keep it short and to the point. 0.92. 